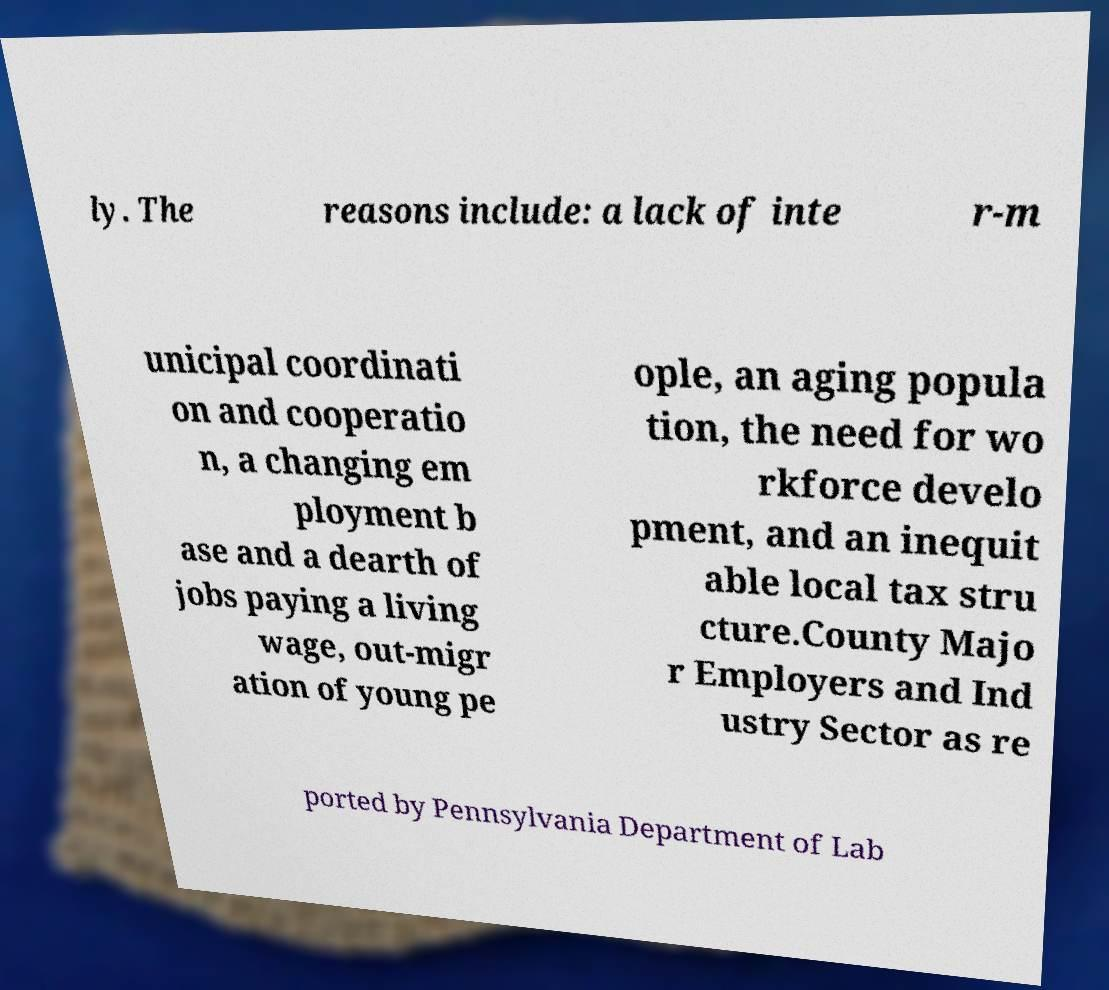Can you accurately transcribe the text from the provided image for me? ly. The reasons include: a lack of inte r-m unicipal coordinati on and cooperatio n, a changing em ployment b ase and a dearth of jobs paying a living wage, out-migr ation of young pe ople, an aging popula tion, the need for wo rkforce develo pment, and an inequit able local tax stru cture.County Majo r Employers and Ind ustry Sector as re ported by Pennsylvania Department of Lab 